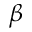Convert formula to latex. <formula><loc_0><loc_0><loc_500><loc_500>\beta</formula> 